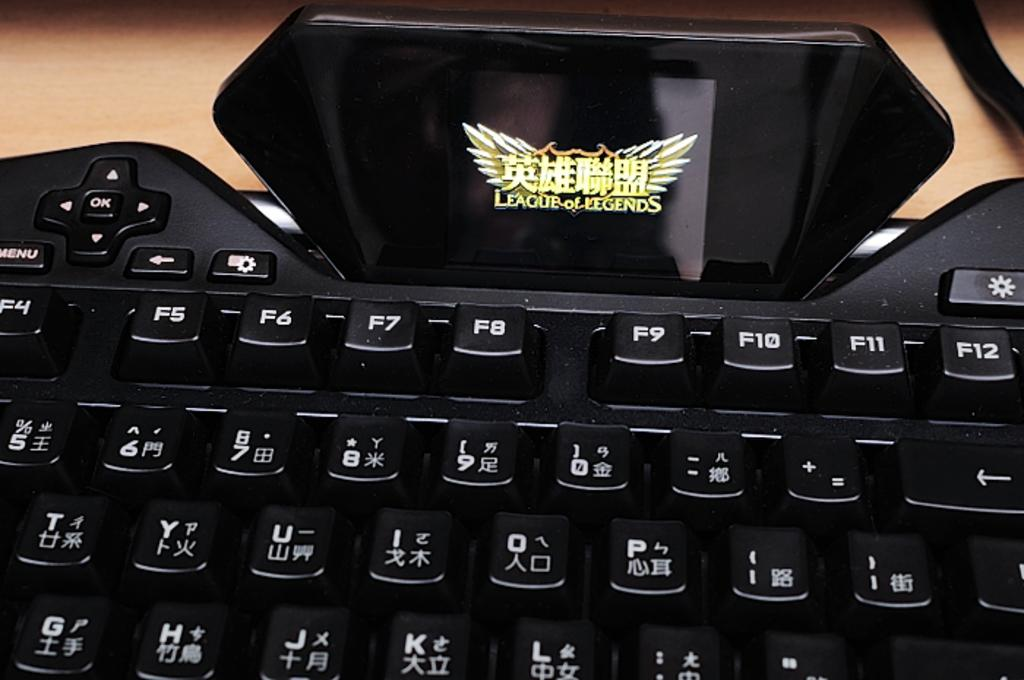<image>
Summarize the visual content of the image. Keyboard with chinese letters and a screen that says League of Legends. 